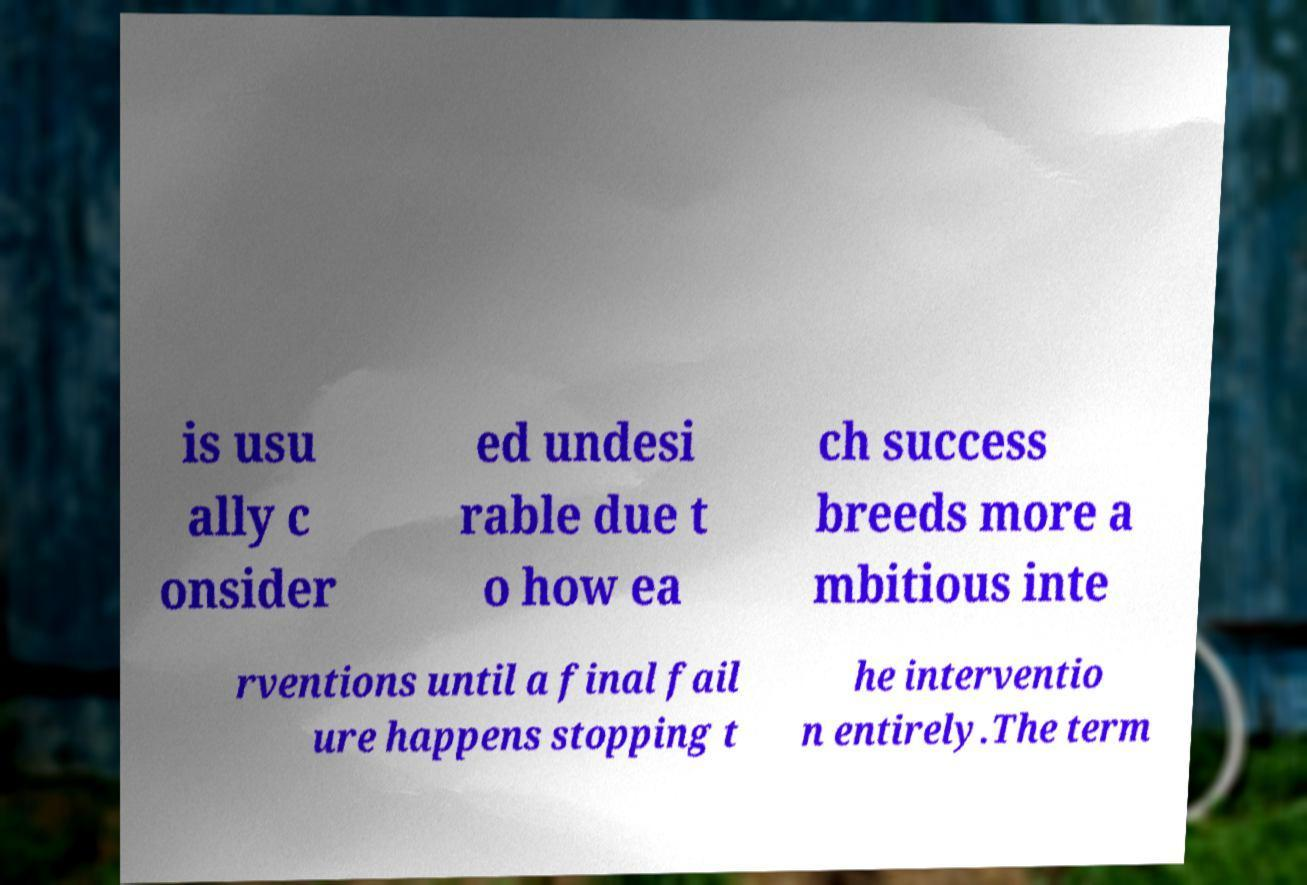Please identify and transcribe the text found in this image. is usu ally c onsider ed undesi rable due t o how ea ch success breeds more a mbitious inte rventions until a final fail ure happens stopping t he interventio n entirely.The term 